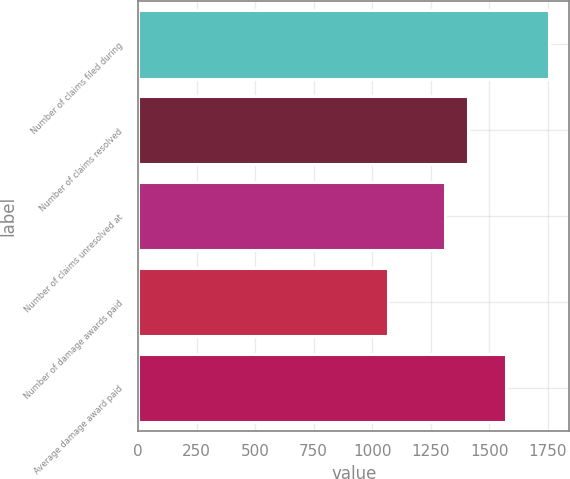Convert chart to OTSL. <chart><loc_0><loc_0><loc_500><loc_500><bar_chart><fcel>Number of claims filed during<fcel>Number of claims resolved<fcel>Number of claims unresolved at<fcel>Number of damage awards paid<fcel>Average damage award paid<nl><fcel>1755<fcel>1410<fcel>1310<fcel>1070<fcel>1574<nl></chart> 